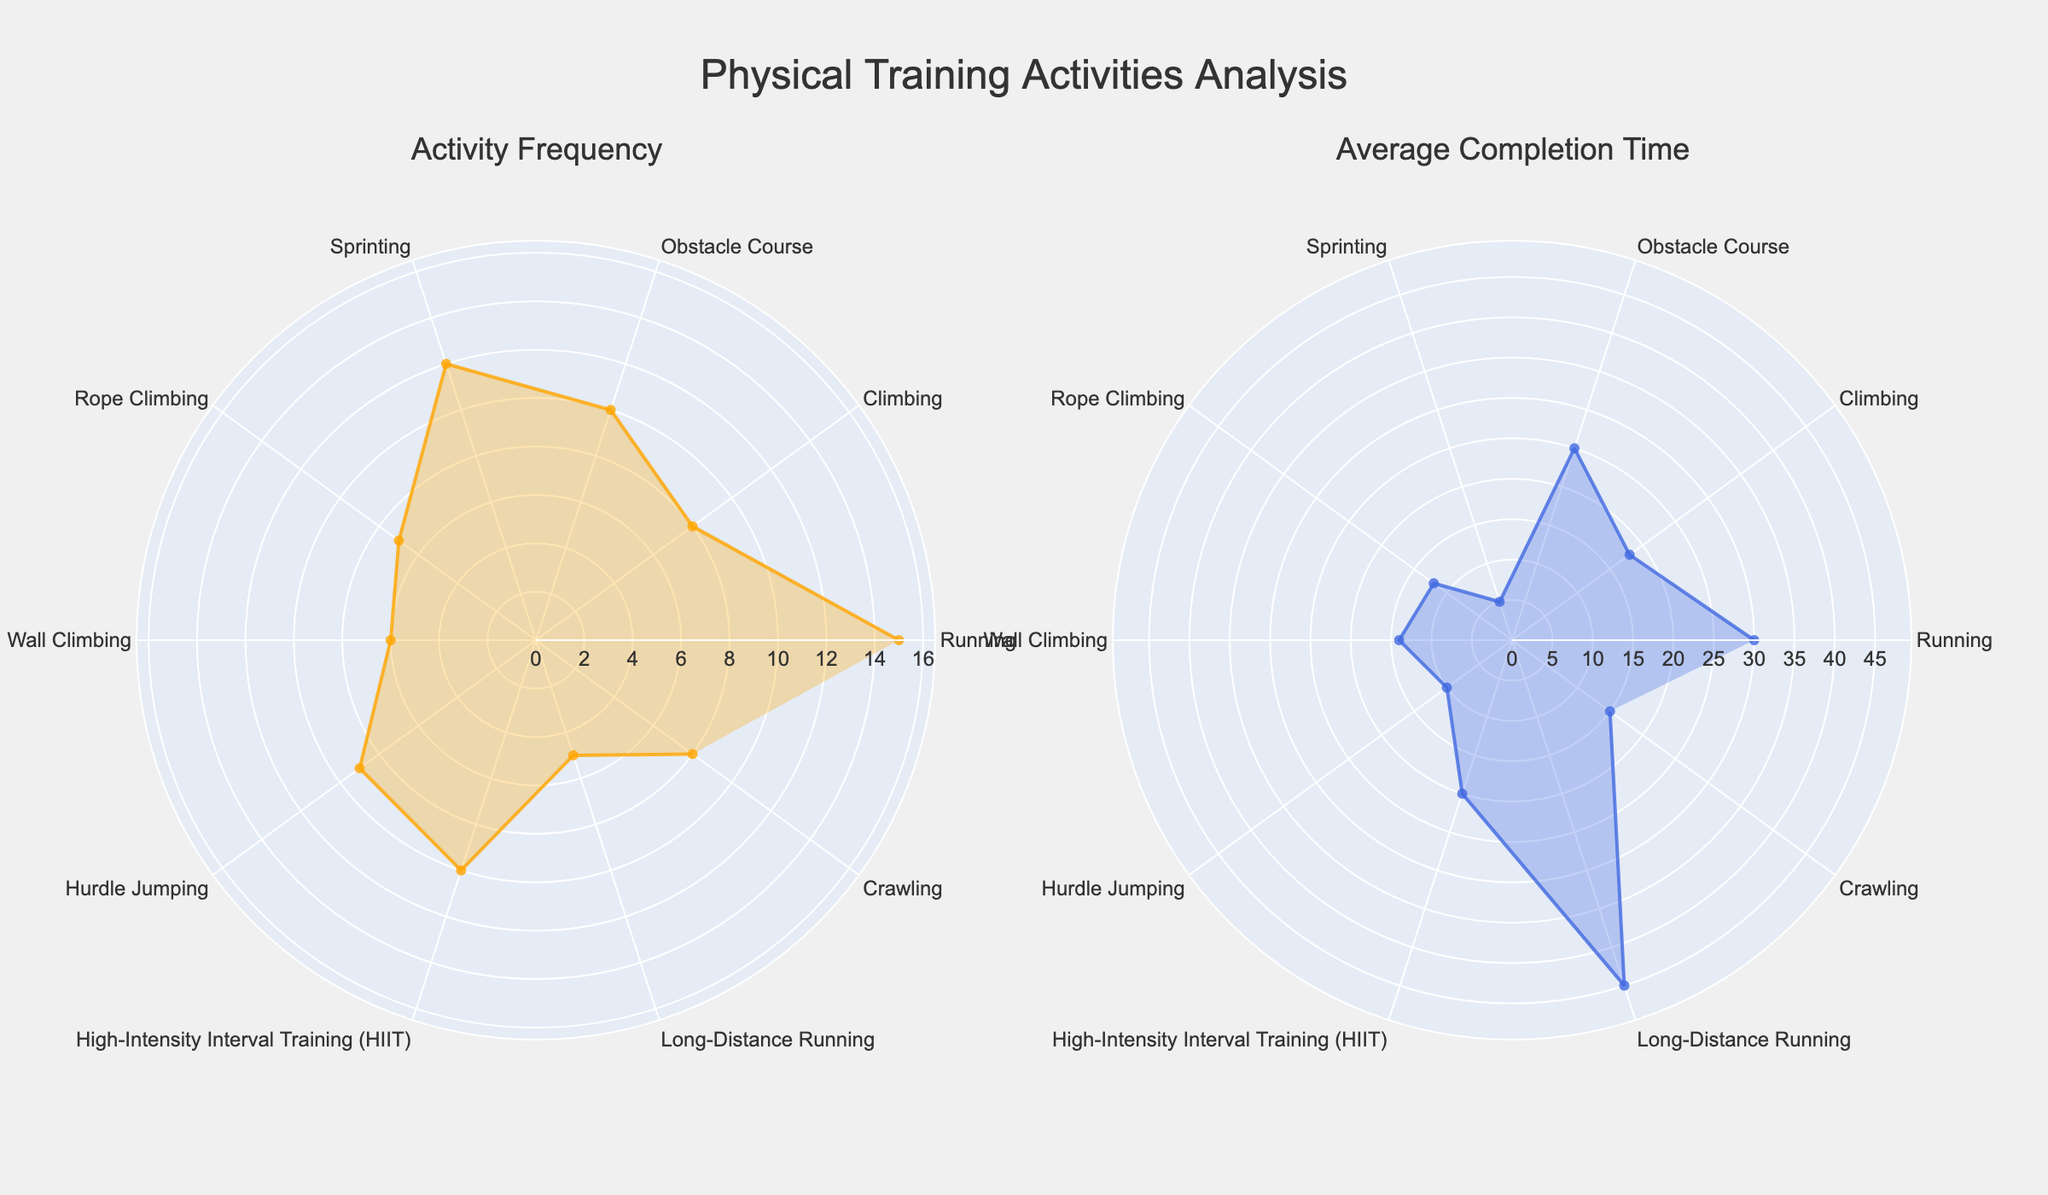How many activities are displayed in the Frequency subplot? To determine the number of activities, we look at the number of distinct data points (spokes on the rose chart) in the Frequency subplot. Count the labels around the chart.
Answer: 10 Which activity has the highest frequency? Find the longest radial line in the Frequency subplot, which corresponds to the activity with the highest frequency. The label at the end of this line indicates the activity.
Answer: Running What is the average completion time for Climbing? Identify the "Climbing" activity in the Completion Time subplot. Read off the radial distance (using the appropriate scale) to find the average completion time.
Answer: 18 minutes Compare the frequencies of Running and Sprinting. Which one is greater and by how much? Locate the radial lines for "Running" and "Sprinting" in the Frequency subplot. Measure the lengths of these lines and subtract the smaller from the larger to find the difference. Running has a frequency of 15, and Sprinting has 12. The difference is 15 - 12 = 3.
Answer: Running by 3 Which activity has the longest average completion time? Look at the radial lines in the Completion Time subplot. The longest line represents the activity with the highest average completion time. Identify the corresponding label.
Answer: Long-Distance Running What is the difference between the completion times of Rope Climbing and Wall Climbing? Identify the radial lines for "Rope Climbing" and "Wall Climbing" in the Completion Time subplot. Measure the lengths of these lines and subtract to find the difference. Rope Climbing is 12 minutes and Wall Climbing is 14 minutes. The difference is 14 - 12 = 2.
Answer: 2 minutes Which two activities have the closest frequencies? Compare the lengths of the radial lines in the Frequency subplot and identify the two lines that are closest in length.
Answer: Obstacle Course and HIIT How many activities have an average completion time of under 20 minutes? Count the number of radial lines in the Completion Time subplot that are less than 20 minutes long.
Answer: 7 Is the frequency of Hurdle Jumping greater than or equal to that of Climbing? Compare the lengths of the radial lines for "Hurdle Jumping" and "Climbing" in the Frequency subplot. Determine if the line for Hurdle Jumping is longer or equal in length to the line for Climbing.
Answer: Yes 